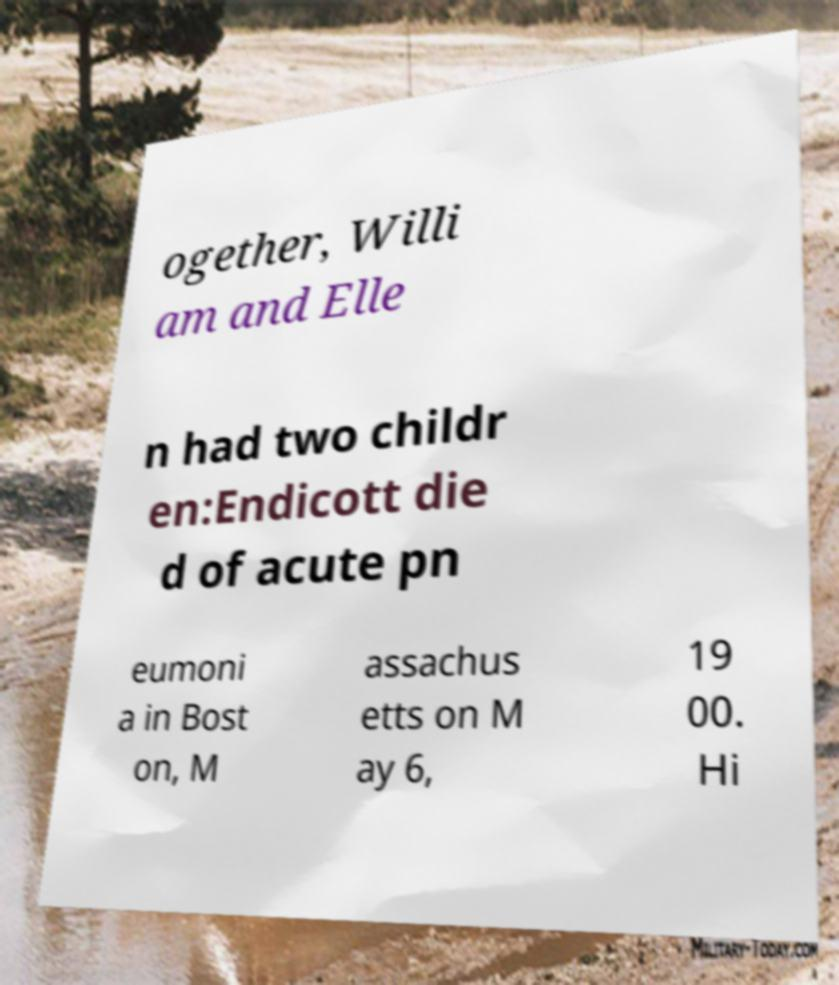Could you assist in decoding the text presented in this image and type it out clearly? ogether, Willi am and Elle n had two childr en:Endicott die d of acute pn eumoni a in Bost on, M assachus etts on M ay 6, 19 00. Hi 